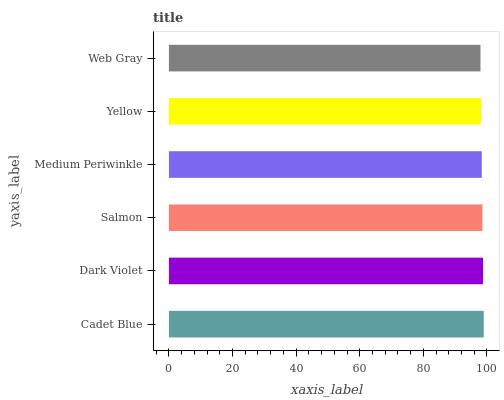Is Web Gray the minimum?
Answer yes or no. Yes. Is Cadet Blue the maximum?
Answer yes or no. Yes. Is Dark Violet the minimum?
Answer yes or no. No. Is Dark Violet the maximum?
Answer yes or no. No. Is Cadet Blue greater than Dark Violet?
Answer yes or no. Yes. Is Dark Violet less than Cadet Blue?
Answer yes or no. Yes. Is Dark Violet greater than Cadet Blue?
Answer yes or no. No. Is Cadet Blue less than Dark Violet?
Answer yes or no. No. Is Salmon the high median?
Answer yes or no. Yes. Is Medium Periwinkle the low median?
Answer yes or no. Yes. Is Yellow the high median?
Answer yes or no. No. Is Cadet Blue the low median?
Answer yes or no. No. 